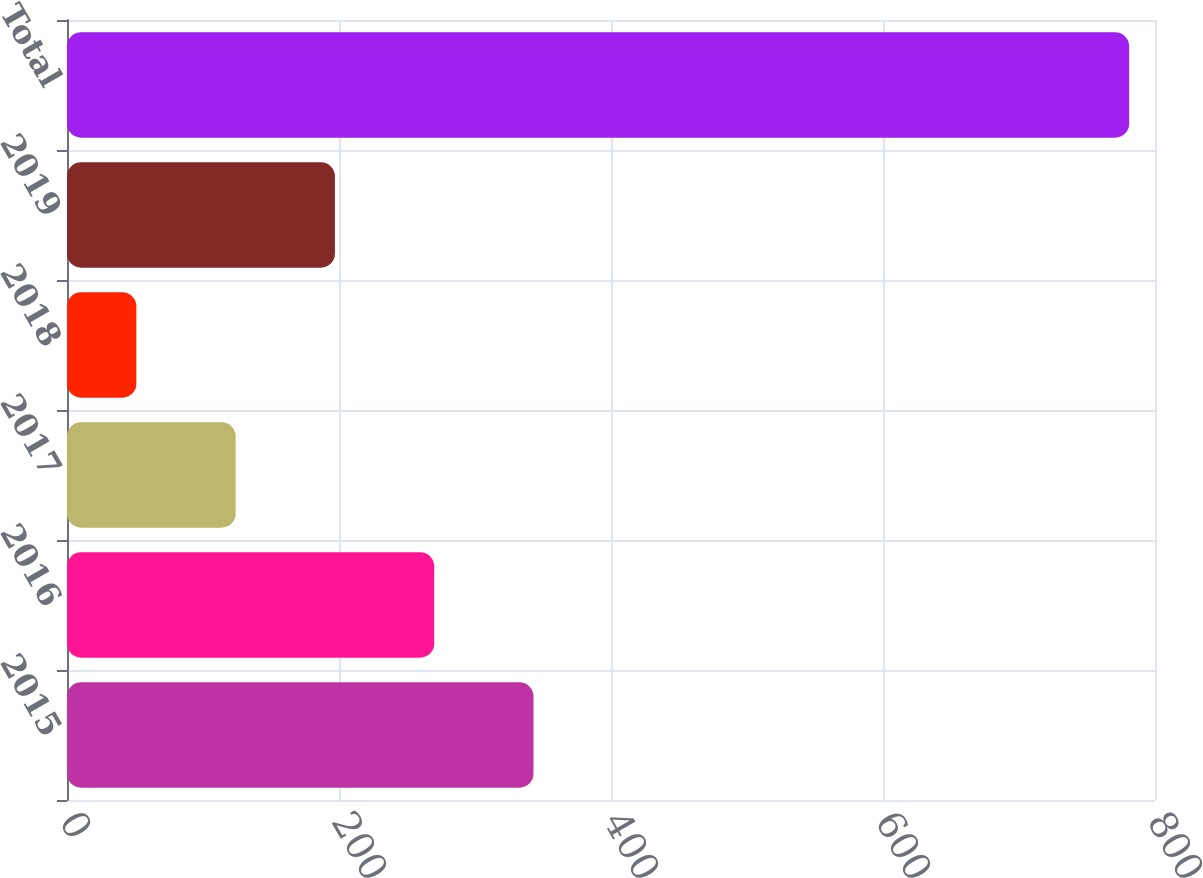Convert chart to OTSL. <chart><loc_0><loc_0><loc_500><loc_500><bar_chart><fcel>2015<fcel>2016<fcel>2017<fcel>2018<fcel>2019<fcel>Total<nl><fcel>343<fcel>270<fcel>124<fcel>51<fcel>197<fcel>781<nl></chart> 